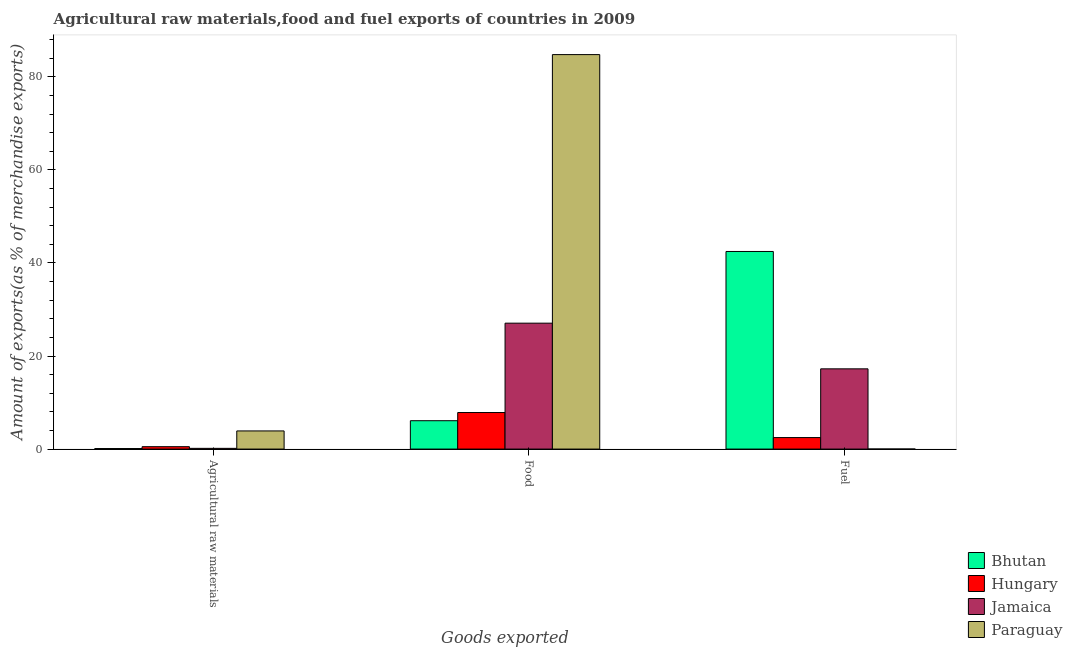Are the number of bars per tick equal to the number of legend labels?
Your answer should be very brief. Yes. How many bars are there on the 1st tick from the left?
Make the answer very short. 4. How many bars are there on the 3rd tick from the right?
Keep it short and to the point. 4. What is the label of the 2nd group of bars from the left?
Offer a terse response. Food. What is the percentage of fuel exports in Paraguay?
Keep it short and to the point. 0.01. Across all countries, what is the maximum percentage of food exports?
Provide a short and direct response. 84.78. Across all countries, what is the minimum percentage of raw materials exports?
Ensure brevity in your answer.  0.11. In which country was the percentage of fuel exports maximum?
Offer a terse response. Bhutan. In which country was the percentage of food exports minimum?
Offer a very short reply. Bhutan. What is the total percentage of fuel exports in the graph?
Ensure brevity in your answer.  62.2. What is the difference between the percentage of food exports in Bhutan and that in Hungary?
Your answer should be compact. -1.76. What is the difference between the percentage of food exports in Bhutan and the percentage of fuel exports in Paraguay?
Make the answer very short. 6.09. What is the average percentage of fuel exports per country?
Make the answer very short. 15.55. What is the difference between the percentage of fuel exports and percentage of food exports in Hungary?
Your answer should be compact. -5.38. In how many countries, is the percentage of food exports greater than 60 %?
Your answer should be very brief. 1. What is the ratio of the percentage of raw materials exports in Paraguay to that in Hungary?
Keep it short and to the point. 7.56. Is the percentage of food exports in Paraguay less than that in Bhutan?
Your response must be concise. No. What is the difference between the highest and the second highest percentage of raw materials exports?
Make the answer very short. 3.39. What is the difference between the highest and the lowest percentage of food exports?
Your answer should be very brief. 78.69. What does the 3rd bar from the left in Food represents?
Keep it short and to the point. Jamaica. What does the 3rd bar from the right in Fuel represents?
Offer a terse response. Hungary. How many bars are there?
Ensure brevity in your answer.  12. Are all the bars in the graph horizontal?
Provide a short and direct response. No. How many legend labels are there?
Make the answer very short. 4. How are the legend labels stacked?
Make the answer very short. Vertical. What is the title of the graph?
Offer a terse response. Agricultural raw materials,food and fuel exports of countries in 2009. What is the label or title of the X-axis?
Give a very brief answer. Goods exported. What is the label or title of the Y-axis?
Your response must be concise. Amount of exports(as % of merchandise exports). What is the Amount of exports(as % of merchandise exports) in Bhutan in Agricultural raw materials?
Provide a succinct answer. 0.11. What is the Amount of exports(as % of merchandise exports) in Hungary in Agricultural raw materials?
Your response must be concise. 0.52. What is the Amount of exports(as % of merchandise exports) of Jamaica in Agricultural raw materials?
Provide a succinct answer. 0.16. What is the Amount of exports(as % of merchandise exports) in Paraguay in Agricultural raw materials?
Keep it short and to the point. 3.9. What is the Amount of exports(as % of merchandise exports) in Bhutan in Food?
Give a very brief answer. 6.09. What is the Amount of exports(as % of merchandise exports) in Hungary in Food?
Provide a short and direct response. 7.86. What is the Amount of exports(as % of merchandise exports) in Jamaica in Food?
Make the answer very short. 27.06. What is the Amount of exports(as % of merchandise exports) of Paraguay in Food?
Your response must be concise. 84.78. What is the Amount of exports(as % of merchandise exports) in Bhutan in Fuel?
Keep it short and to the point. 42.47. What is the Amount of exports(as % of merchandise exports) of Hungary in Fuel?
Make the answer very short. 2.47. What is the Amount of exports(as % of merchandise exports) in Jamaica in Fuel?
Your answer should be very brief. 17.24. What is the Amount of exports(as % of merchandise exports) in Paraguay in Fuel?
Provide a succinct answer. 0.01. Across all Goods exported, what is the maximum Amount of exports(as % of merchandise exports) of Bhutan?
Provide a short and direct response. 42.47. Across all Goods exported, what is the maximum Amount of exports(as % of merchandise exports) in Hungary?
Your answer should be very brief. 7.86. Across all Goods exported, what is the maximum Amount of exports(as % of merchandise exports) of Jamaica?
Keep it short and to the point. 27.06. Across all Goods exported, what is the maximum Amount of exports(as % of merchandise exports) of Paraguay?
Ensure brevity in your answer.  84.78. Across all Goods exported, what is the minimum Amount of exports(as % of merchandise exports) of Bhutan?
Give a very brief answer. 0.11. Across all Goods exported, what is the minimum Amount of exports(as % of merchandise exports) in Hungary?
Give a very brief answer. 0.52. Across all Goods exported, what is the minimum Amount of exports(as % of merchandise exports) in Jamaica?
Ensure brevity in your answer.  0.16. Across all Goods exported, what is the minimum Amount of exports(as % of merchandise exports) of Paraguay?
Your answer should be compact. 0.01. What is the total Amount of exports(as % of merchandise exports) in Bhutan in the graph?
Offer a very short reply. 48.68. What is the total Amount of exports(as % of merchandise exports) of Hungary in the graph?
Your answer should be very brief. 10.85. What is the total Amount of exports(as % of merchandise exports) in Jamaica in the graph?
Your answer should be compact. 44.46. What is the total Amount of exports(as % of merchandise exports) in Paraguay in the graph?
Make the answer very short. 88.69. What is the difference between the Amount of exports(as % of merchandise exports) in Bhutan in Agricultural raw materials and that in Food?
Make the answer very short. -5.98. What is the difference between the Amount of exports(as % of merchandise exports) in Hungary in Agricultural raw materials and that in Food?
Provide a short and direct response. -7.34. What is the difference between the Amount of exports(as % of merchandise exports) of Jamaica in Agricultural raw materials and that in Food?
Keep it short and to the point. -26.91. What is the difference between the Amount of exports(as % of merchandise exports) in Paraguay in Agricultural raw materials and that in Food?
Ensure brevity in your answer.  -80.88. What is the difference between the Amount of exports(as % of merchandise exports) of Bhutan in Agricultural raw materials and that in Fuel?
Keep it short and to the point. -42.35. What is the difference between the Amount of exports(as % of merchandise exports) of Hungary in Agricultural raw materials and that in Fuel?
Keep it short and to the point. -1.96. What is the difference between the Amount of exports(as % of merchandise exports) in Jamaica in Agricultural raw materials and that in Fuel?
Your answer should be very brief. -17.09. What is the difference between the Amount of exports(as % of merchandise exports) of Paraguay in Agricultural raw materials and that in Fuel?
Ensure brevity in your answer.  3.89. What is the difference between the Amount of exports(as % of merchandise exports) of Bhutan in Food and that in Fuel?
Provide a succinct answer. -36.37. What is the difference between the Amount of exports(as % of merchandise exports) of Hungary in Food and that in Fuel?
Offer a very short reply. 5.38. What is the difference between the Amount of exports(as % of merchandise exports) of Jamaica in Food and that in Fuel?
Your answer should be compact. 9.82. What is the difference between the Amount of exports(as % of merchandise exports) in Paraguay in Food and that in Fuel?
Make the answer very short. 84.77. What is the difference between the Amount of exports(as % of merchandise exports) in Bhutan in Agricultural raw materials and the Amount of exports(as % of merchandise exports) in Hungary in Food?
Provide a short and direct response. -7.74. What is the difference between the Amount of exports(as % of merchandise exports) of Bhutan in Agricultural raw materials and the Amount of exports(as % of merchandise exports) of Jamaica in Food?
Make the answer very short. -26.95. What is the difference between the Amount of exports(as % of merchandise exports) of Bhutan in Agricultural raw materials and the Amount of exports(as % of merchandise exports) of Paraguay in Food?
Offer a very short reply. -84.67. What is the difference between the Amount of exports(as % of merchandise exports) of Hungary in Agricultural raw materials and the Amount of exports(as % of merchandise exports) of Jamaica in Food?
Keep it short and to the point. -26.55. What is the difference between the Amount of exports(as % of merchandise exports) of Hungary in Agricultural raw materials and the Amount of exports(as % of merchandise exports) of Paraguay in Food?
Ensure brevity in your answer.  -84.27. What is the difference between the Amount of exports(as % of merchandise exports) in Jamaica in Agricultural raw materials and the Amount of exports(as % of merchandise exports) in Paraguay in Food?
Your answer should be very brief. -84.62. What is the difference between the Amount of exports(as % of merchandise exports) in Bhutan in Agricultural raw materials and the Amount of exports(as % of merchandise exports) in Hungary in Fuel?
Keep it short and to the point. -2.36. What is the difference between the Amount of exports(as % of merchandise exports) in Bhutan in Agricultural raw materials and the Amount of exports(as % of merchandise exports) in Jamaica in Fuel?
Give a very brief answer. -17.13. What is the difference between the Amount of exports(as % of merchandise exports) of Bhutan in Agricultural raw materials and the Amount of exports(as % of merchandise exports) of Paraguay in Fuel?
Provide a succinct answer. 0.11. What is the difference between the Amount of exports(as % of merchandise exports) in Hungary in Agricultural raw materials and the Amount of exports(as % of merchandise exports) in Jamaica in Fuel?
Ensure brevity in your answer.  -16.73. What is the difference between the Amount of exports(as % of merchandise exports) of Hungary in Agricultural raw materials and the Amount of exports(as % of merchandise exports) of Paraguay in Fuel?
Your response must be concise. 0.51. What is the difference between the Amount of exports(as % of merchandise exports) of Jamaica in Agricultural raw materials and the Amount of exports(as % of merchandise exports) of Paraguay in Fuel?
Keep it short and to the point. 0.15. What is the difference between the Amount of exports(as % of merchandise exports) of Bhutan in Food and the Amount of exports(as % of merchandise exports) of Hungary in Fuel?
Keep it short and to the point. 3.62. What is the difference between the Amount of exports(as % of merchandise exports) in Bhutan in Food and the Amount of exports(as % of merchandise exports) in Jamaica in Fuel?
Your answer should be very brief. -11.15. What is the difference between the Amount of exports(as % of merchandise exports) of Bhutan in Food and the Amount of exports(as % of merchandise exports) of Paraguay in Fuel?
Provide a short and direct response. 6.09. What is the difference between the Amount of exports(as % of merchandise exports) in Hungary in Food and the Amount of exports(as % of merchandise exports) in Jamaica in Fuel?
Your answer should be very brief. -9.39. What is the difference between the Amount of exports(as % of merchandise exports) in Hungary in Food and the Amount of exports(as % of merchandise exports) in Paraguay in Fuel?
Your response must be concise. 7.85. What is the difference between the Amount of exports(as % of merchandise exports) in Jamaica in Food and the Amount of exports(as % of merchandise exports) in Paraguay in Fuel?
Your answer should be very brief. 27.05. What is the average Amount of exports(as % of merchandise exports) in Bhutan per Goods exported?
Your answer should be very brief. 16.23. What is the average Amount of exports(as % of merchandise exports) in Hungary per Goods exported?
Offer a terse response. 3.62. What is the average Amount of exports(as % of merchandise exports) of Jamaica per Goods exported?
Keep it short and to the point. 14.82. What is the average Amount of exports(as % of merchandise exports) of Paraguay per Goods exported?
Offer a terse response. 29.56. What is the difference between the Amount of exports(as % of merchandise exports) in Bhutan and Amount of exports(as % of merchandise exports) in Hungary in Agricultural raw materials?
Provide a succinct answer. -0.4. What is the difference between the Amount of exports(as % of merchandise exports) in Bhutan and Amount of exports(as % of merchandise exports) in Jamaica in Agricultural raw materials?
Provide a short and direct response. -0.04. What is the difference between the Amount of exports(as % of merchandise exports) in Bhutan and Amount of exports(as % of merchandise exports) in Paraguay in Agricultural raw materials?
Offer a terse response. -3.79. What is the difference between the Amount of exports(as % of merchandise exports) in Hungary and Amount of exports(as % of merchandise exports) in Jamaica in Agricultural raw materials?
Provide a succinct answer. 0.36. What is the difference between the Amount of exports(as % of merchandise exports) in Hungary and Amount of exports(as % of merchandise exports) in Paraguay in Agricultural raw materials?
Keep it short and to the point. -3.39. What is the difference between the Amount of exports(as % of merchandise exports) in Jamaica and Amount of exports(as % of merchandise exports) in Paraguay in Agricultural raw materials?
Offer a terse response. -3.74. What is the difference between the Amount of exports(as % of merchandise exports) of Bhutan and Amount of exports(as % of merchandise exports) of Hungary in Food?
Offer a very short reply. -1.76. What is the difference between the Amount of exports(as % of merchandise exports) of Bhutan and Amount of exports(as % of merchandise exports) of Jamaica in Food?
Ensure brevity in your answer.  -20.97. What is the difference between the Amount of exports(as % of merchandise exports) in Bhutan and Amount of exports(as % of merchandise exports) in Paraguay in Food?
Your answer should be compact. -78.69. What is the difference between the Amount of exports(as % of merchandise exports) in Hungary and Amount of exports(as % of merchandise exports) in Jamaica in Food?
Ensure brevity in your answer.  -19.21. What is the difference between the Amount of exports(as % of merchandise exports) in Hungary and Amount of exports(as % of merchandise exports) in Paraguay in Food?
Ensure brevity in your answer.  -76.92. What is the difference between the Amount of exports(as % of merchandise exports) in Jamaica and Amount of exports(as % of merchandise exports) in Paraguay in Food?
Your response must be concise. -57.72. What is the difference between the Amount of exports(as % of merchandise exports) of Bhutan and Amount of exports(as % of merchandise exports) of Hungary in Fuel?
Offer a very short reply. 39.99. What is the difference between the Amount of exports(as % of merchandise exports) in Bhutan and Amount of exports(as % of merchandise exports) in Jamaica in Fuel?
Ensure brevity in your answer.  25.22. What is the difference between the Amount of exports(as % of merchandise exports) of Bhutan and Amount of exports(as % of merchandise exports) of Paraguay in Fuel?
Keep it short and to the point. 42.46. What is the difference between the Amount of exports(as % of merchandise exports) of Hungary and Amount of exports(as % of merchandise exports) of Jamaica in Fuel?
Your answer should be compact. -14.77. What is the difference between the Amount of exports(as % of merchandise exports) of Hungary and Amount of exports(as % of merchandise exports) of Paraguay in Fuel?
Ensure brevity in your answer.  2.47. What is the difference between the Amount of exports(as % of merchandise exports) in Jamaica and Amount of exports(as % of merchandise exports) in Paraguay in Fuel?
Your response must be concise. 17.24. What is the ratio of the Amount of exports(as % of merchandise exports) in Bhutan in Agricultural raw materials to that in Food?
Keep it short and to the point. 0.02. What is the ratio of the Amount of exports(as % of merchandise exports) in Hungary in Agricultural raw materials to that in Food?
Ensure brevity in your answer.  0.07. What is the ratio of the Amount of exports(as % of merchandise exports) in Jamaica in Agricultural raw materials to that in Food?
Provide a succinct answer. 0.01. What is the ratio of the Amount of exports(as % of merchandise exports) in Paraguay in Agricultural raw materials to that in Food?
Provide a short and direct response. 0.05. What is the ratio of the Amount of exports(as % of merchandise exports) of Bhutan in Agricultural raw materials to that in Fuel?
Make the answer very short. 0. What is the ratio of the Amount of exports(as % of merchandise exports) of Hungary in Agricultural raw materials to that in Fuel?
Offer a very short reply. 0.21. What is the ratio of the Amount of exports(as % of merchandise exports) in Jamaica in Agricultural raw materials to that in Fuel?
Your answer should be very brief. 0.01. What is the ratio of the Amount of exports(as % of merchandise exports) in Paraguay in Agricultural raw materials to that in Fuel?
Offer a terse response. 455.63. What is the ratio of the Amount of exports(as % of merchandise exports) in Bhutan in Food to that in Fuel?
Provide a short and direct response. 0.14. What is the ratio of the Amount of exports(as % of merchandise exports) of Hungary in Food to that in Fuel?
Keep it short and to the point. 3.18. What is the ratio of the Amount of exports(as % of merchandise exports) of Jamaica in Food to that in Fuel?
Ensure brevity in your answer.  1.57. What is the ratio of the Amount of exports(as % of merchandise exports) in Paraguay in Food to that in Fuel?
Your response must be concise. 9901.78. What is the difference between the highest and the second highest Amount of exports(as % of merchandise exports) of Bhutan?
Give a very brief answer. 36.37. What is the difference between the highest and the second highest Amount of exports(as % of merchandise exports) of Hungary?
Keep it short and to the point. 5.38. What is the difference between the highest and the second highest Amount of exports(as % of merchandise exports) in Jamaica?
Offer a very short reply. 9.82. What is the difference between the highest and the second highest Amount of exports(as % of merchandise exports) of Paraguay?
Your answer should be very brief. 80.88. What is the difference between the highest and the lowest Amount of exports(as % of merchandise exports) of Bhutan?
Offer a very short reply. 42.35. What is the difference between the highest and the lowest Amount of exports(as % of merchandise exports) in Hungary?
Provide a succinct answer. 7.34. What is the difference between the highest and the lowest Amount of exports(as % of merchandise exports) in Jamaica?
Your answer should be very brief. 26.91. What is the difference between the highest and the lowest Amount of exports(as % of merchandise exports) of Paraguay?
Provide a succinct answer. 84.77. 